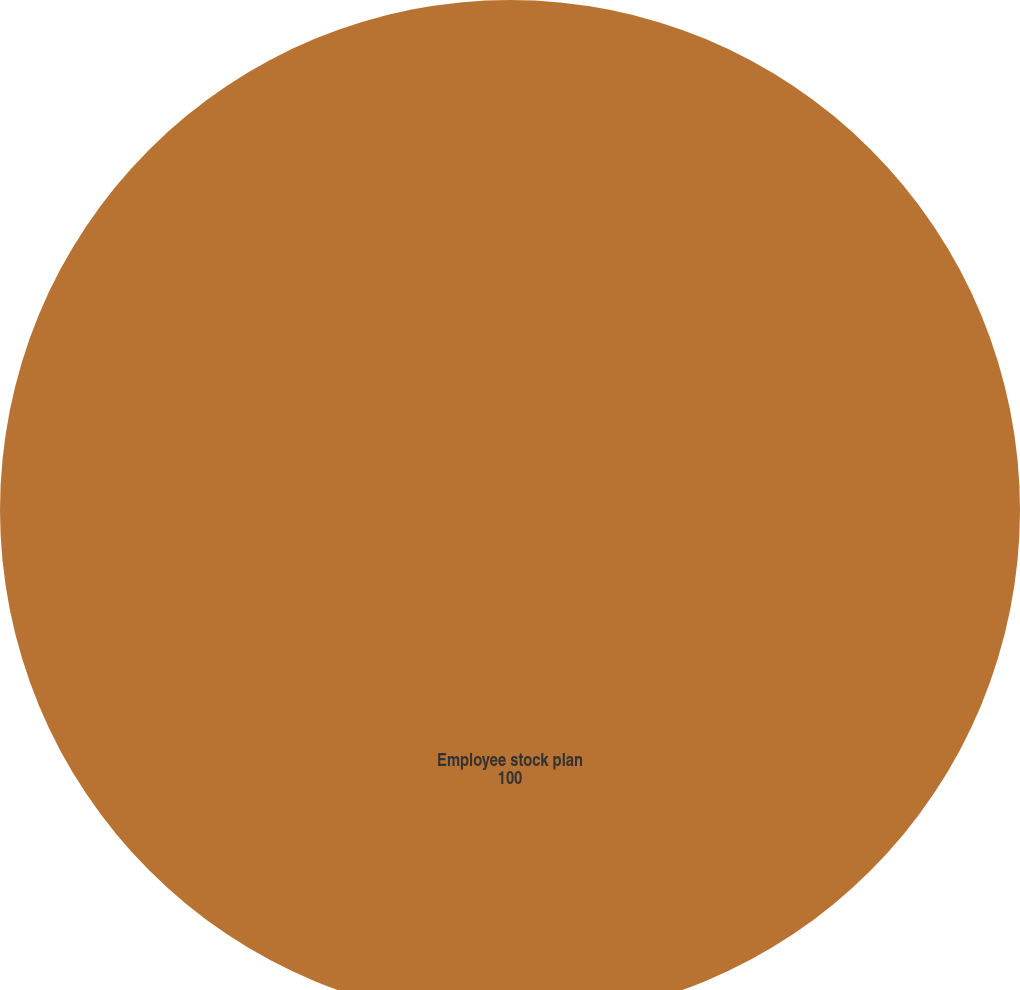<chart> <loc_0><loc_0><loc_500><loc_500><pie_chart><fcel>Employee stock plan<nl><fcel>100.0%<nl></chart> 